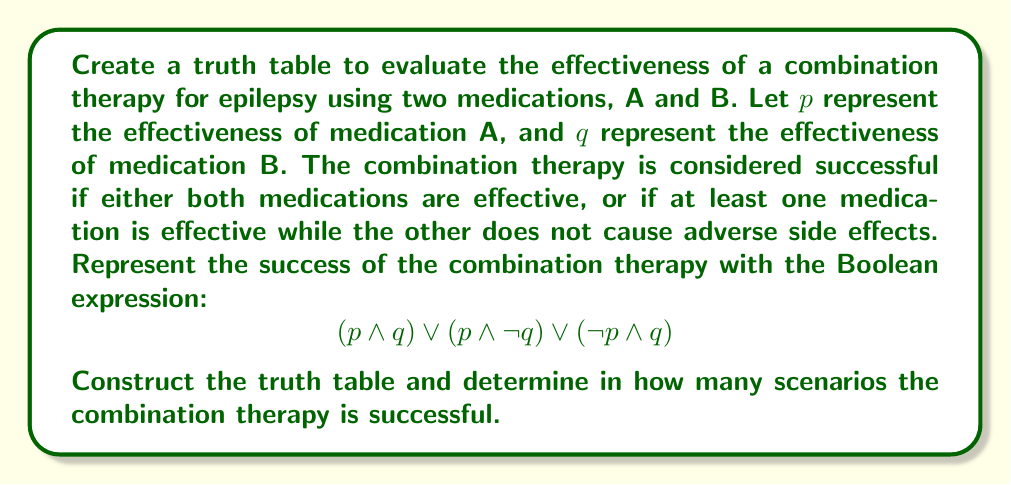Help me with this question. To solve this problem, we'll follow these steps:

1) Identify the variables: $p$ (effectiveness of A) and $q$ (effectiveness of B)

2) Create a truth table with columns for $p$, $q$, and the sub-expressions:
   - $p \land q$
   - $p \land \neg q$
   - $\neg p \land q$
   - $(p \land q) \lor (p \land \neg q) \lor (\neg p \land q)$

3) Fill in the truth table:

   $$\begin{array}{|c|c|c|c|c|c|}
   \hline
   p & q & p \land q & p \land \neg q & \neg p \land q & (p \land q) \lor (p \land \neg q) \lor (\neg p \land q) \\
   \hline
   0 & 0 & 0 & 0 & 0 & 0 \\
   0 & 1 & 0 & 0 & 1 & 1 \\
   1 & 0 & 0 & 1 & 0 & 1 \\
   1 & 1 & 1 & 0 & 0 & 1 \\
   \hline
   \end{array}$$

4) Count the number of rows where the final column (representing the success of the combination therapy) is 1.

In this truth table, we can see that the combination therapy is successful (final column is 1) in 3 out of 4 scenarios:
- When $p = 0$ and $q = 1$
- When $p = 1$ and $q = 0$
- When $p = 1$ and $q = 1$

Therefore, the combination therapy is successful in 3 scenarios.
Answer: 3 scenarios 